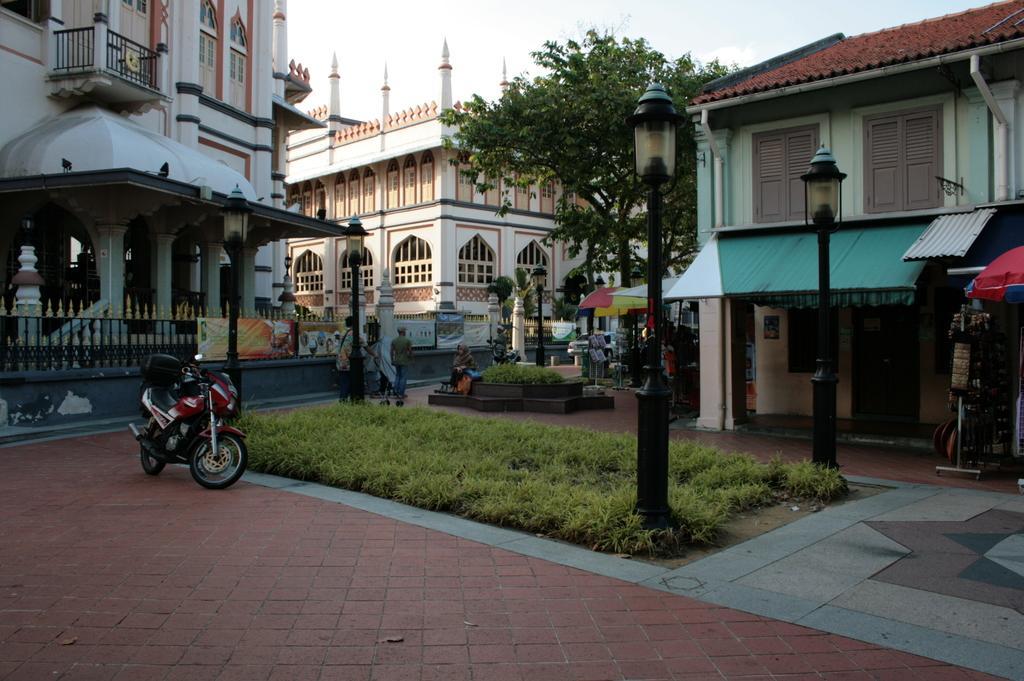Can you describe this image briefly? In this picture I can see the path on which there is a bike and I can see the grass and few light poles. In the center of this picture I can see the buildings, few trees and few people. I can also see few banners. In the background I can see the sky. 